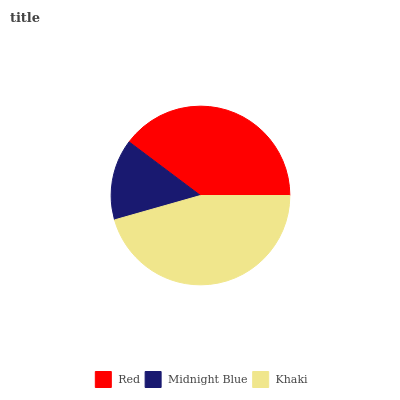Is Midnight Blue the minimum?
Answer yes or no. Yes. Is Khaki the maximum?
Answer yes or no. Yes. Is Khaki the minimum?
Answer yes or no. No. Is Midnight Blue the maximum?
Answer yes or no. No. Is Khaki greater than Midnight Blue?
Answer yes or no. Yes. Is Midnight Blue less than Khaki?
Answer yes or no. Yes. Is Midnight Blue greater than Khaki?
Answer yes or no. No. Is Khaki less than Midnight Blue?
Answer yes or no. No. Is Red the high median?
Answer yes or no. Yes. Is Red the low median?
Answer yes or no. Yes. Is Khaki the high median?
Answer yes or no. No. Is Midnight Blue the low median?
Answer yes or no. No. 